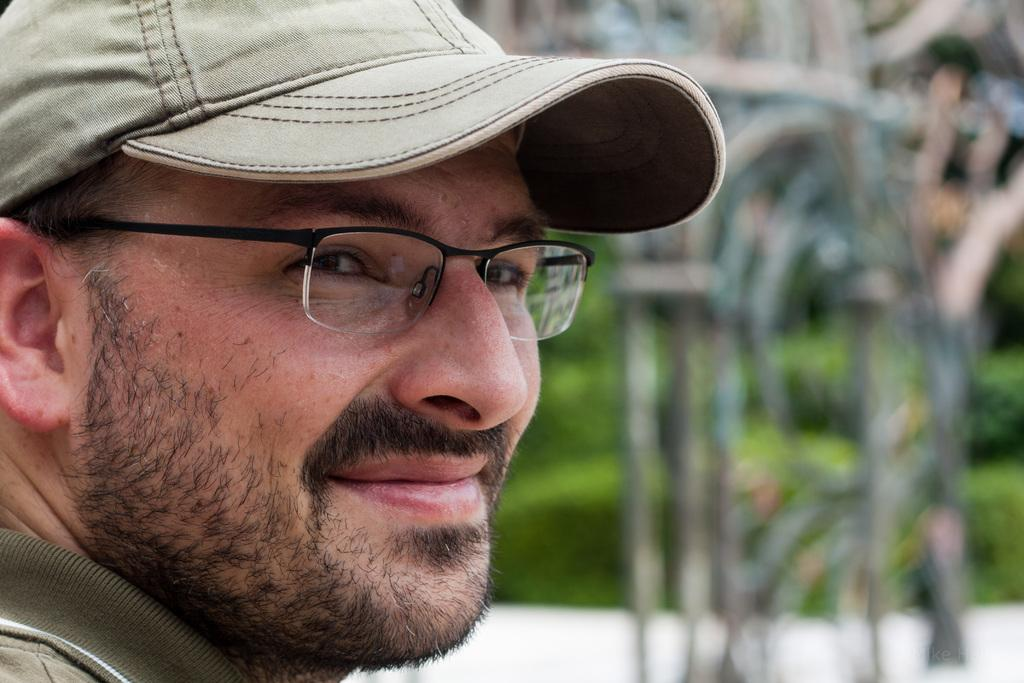Who is present in the image? There is a man in the image. What is the man doing in the image? The man is smiling in the image. What is the man wearing on his upper body? The man is wearing a green t-shirt in the image. What type of headwear is the man wearing? The man is wearing a cap in the image. What type of amusement can be seen in the image? There is no amusement present in the image; it features a man wearing a cap and a green t-shirt while smiling. Can you tell me the level of knowledge the man has about the subject in the image? There is no subject or indication of knowledge in the image; it simply shows a man smiling while wearing a cap and a green t-shirt. 